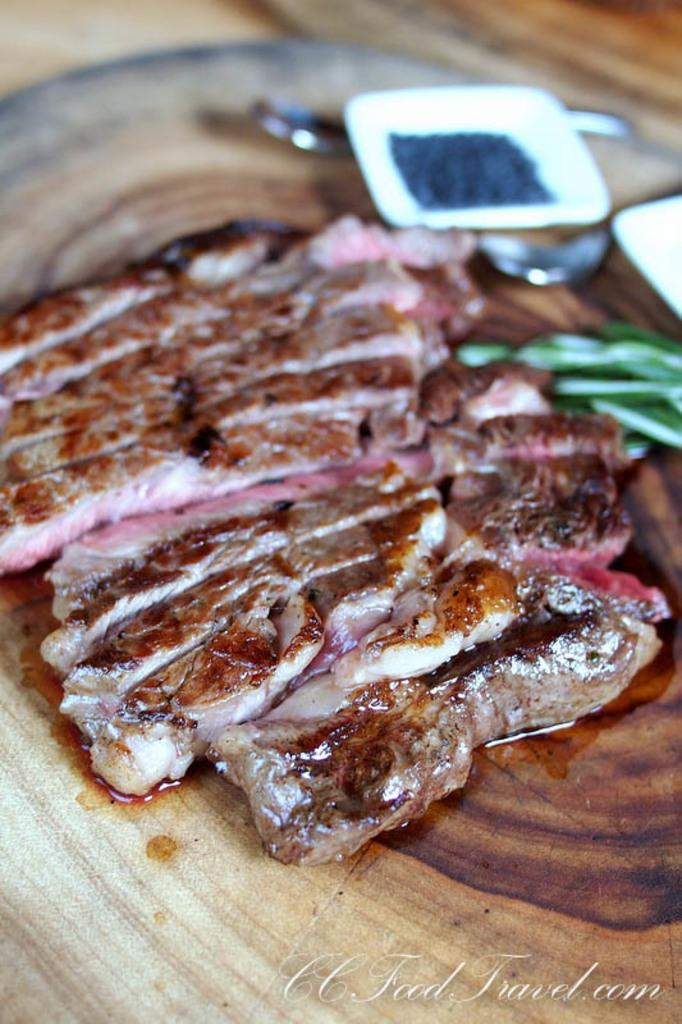What type of food is visible in the image? There is meat in the image. What utensils are present in the image? There are forks in the image. What type of containers are visible in the image? There are bowls in the image. What material is the object at the bottom of the image made of? The object at the bottom of the image is made of wood. What is contained within the bowls in the image? There is food in the bowl. What can be seen at the bottom right of the image? There is text at the bottom right of the image. What type of wheel is visible in the image? There is no wheel present in the image. What kind of toy can be seen in the image? There is no toy present in the image. 